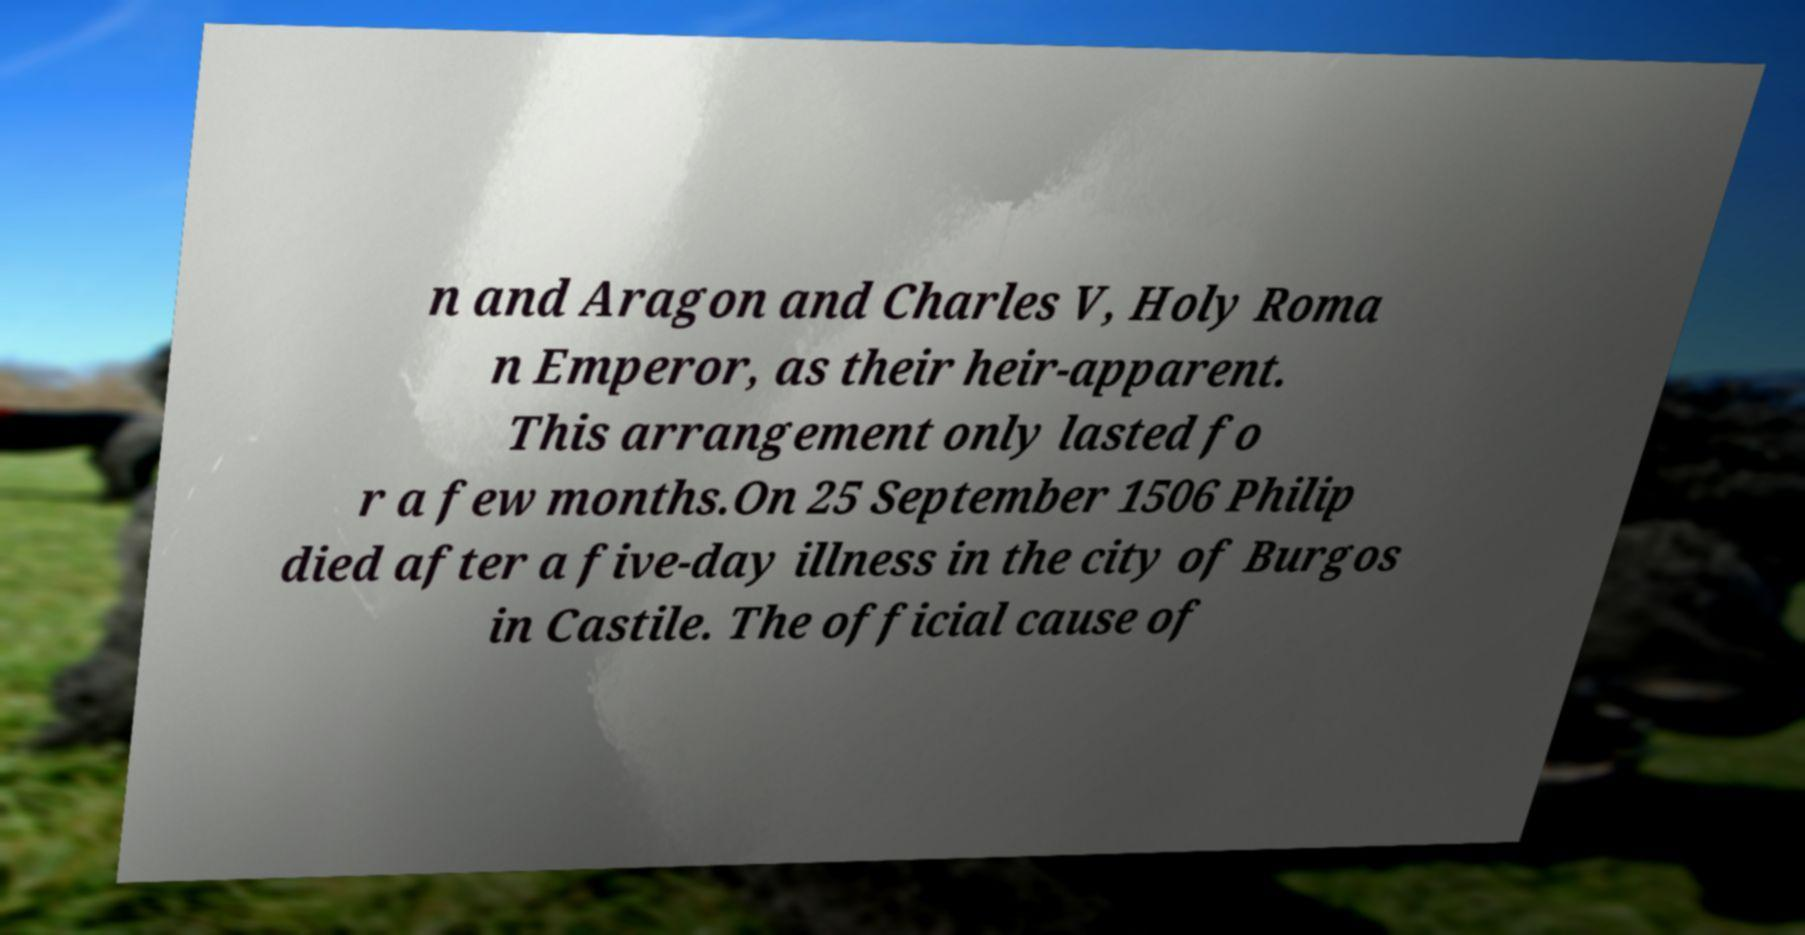Could you extract and type out the text from this image? n and Aragon and Charles V, Holy Roma n Emperor, as their heir-apparent. This arrangement only lasted fo r a few months.On 25 September 1506 Philip died after a five-day illness in the city of Burgos in Castile. The official cause of 